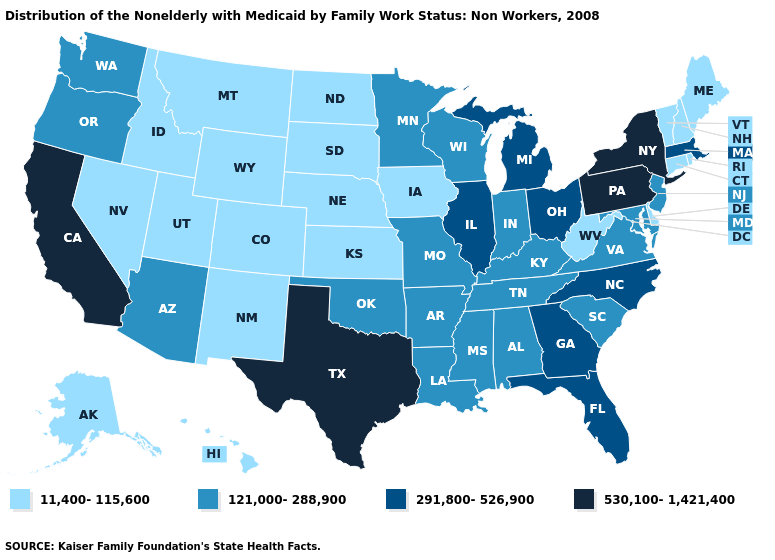What is the value of Michigan?
Be succinct. 291,800-526,900. Which states have the highest value in the USA?
Concise answer only. California, New York, Pennsylvania, Texas. What is the value of Maryland?
Be succinct. 121,000-288,900. Which states have the lowest value in the South?
Short answer required. Delaware, West Virginia. Among the states that border North Carolina , which have the highest value?
Answer briefly. Georgia. Does Florida have the lowest value in the USA?
Keep it brief. No. Name the states that have a value in the range 121,000-288,900?
Be succinct. Alabama, Arizona, Arkansas, Indiana, Kentucky, Louisiana, Maryland, Minnesota, Mississippi, Missouri, New Jersey, Oklahoma, Oregon, South Carolina, Tennessee, Virginia, Washington, Wisconsin. Is the legend a continuous bar?
Concise answer only. No. Which states have the lowest value in the USA?
Give a very brief answer. Alaska, Colorado, Connecticut, Delaware, Hawaii, Idaho, Iowa, Kansas, Maine, Montana, Nebraska, Nevada, New Hampshire, New Mexico, North Dakota, Rhode Island, South Dakota, Utah, Vermont, West Virginia, Wyoming. What is the value of Wisconsin?
Concise answer only. 121,000-288,900. Name the states that have a value in the range 11,400-115,600?
Short answer required. Alaska, Colorado, Connecticut, Delaware, Hawaii, Idaho, Iowa, Kansas, Maine, Montana, Nebraska, Nevada, New Hampshire, New Mexico, North Dakota, Rhode Island, South Dakota, Utah, Vermont, West Virginia, Wyoming. Does the first symbol in the legend represent the smallest category?
Be succinct. Yes. Which states hav the highest value in the West?
Keep it brief. California. Which states have the highest value in the USA?
Give a very brief answer. California, New York, Pennsylvania, Texas. What is the lowest value in the USA?
Keep it brief. 11,400-115,600. 